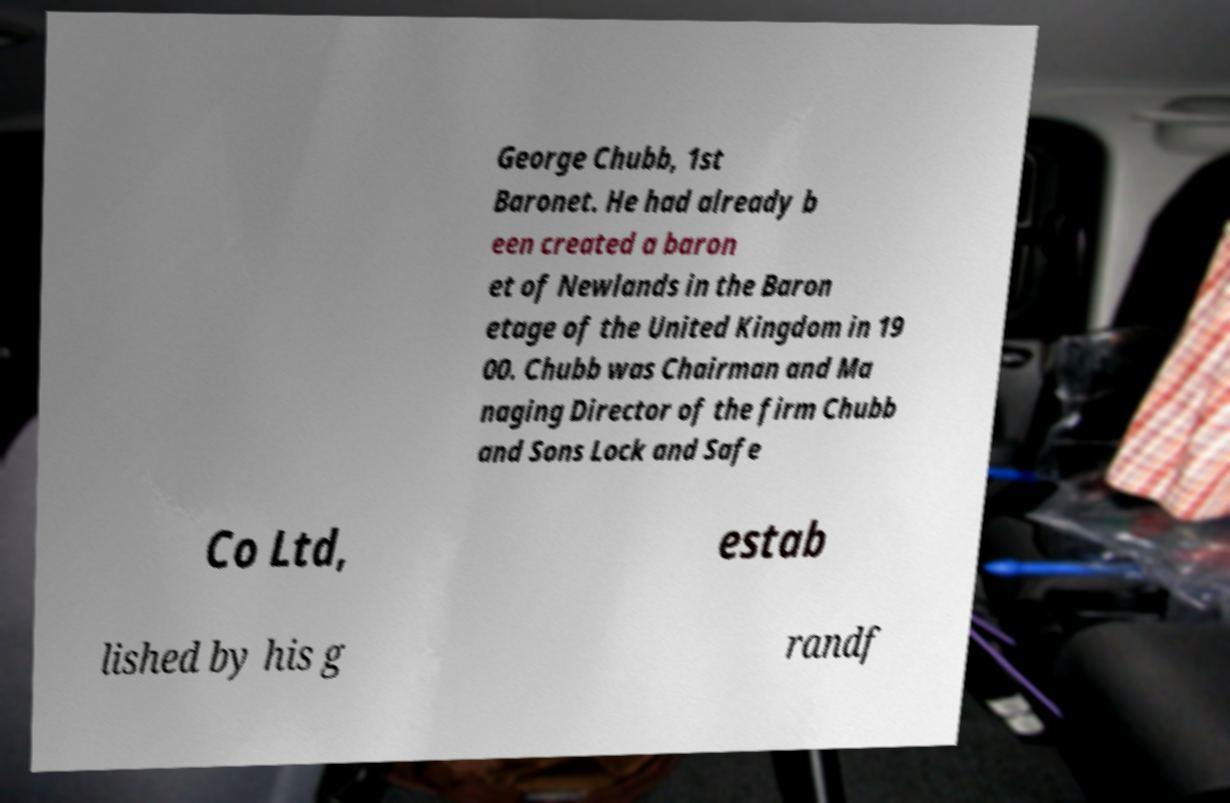What messages or text are displayed in this image? I need them in a readable, typed format. George Chubb, 1st Baronet. He had already b een created a baron et of Newlands in the Baron etage of the United Kingdom in 19 00. Chubb was Chairman and Ma naging Director of the firm Chubb and Sons Lock and Safe Co Ltd, estab lished by his g randf 